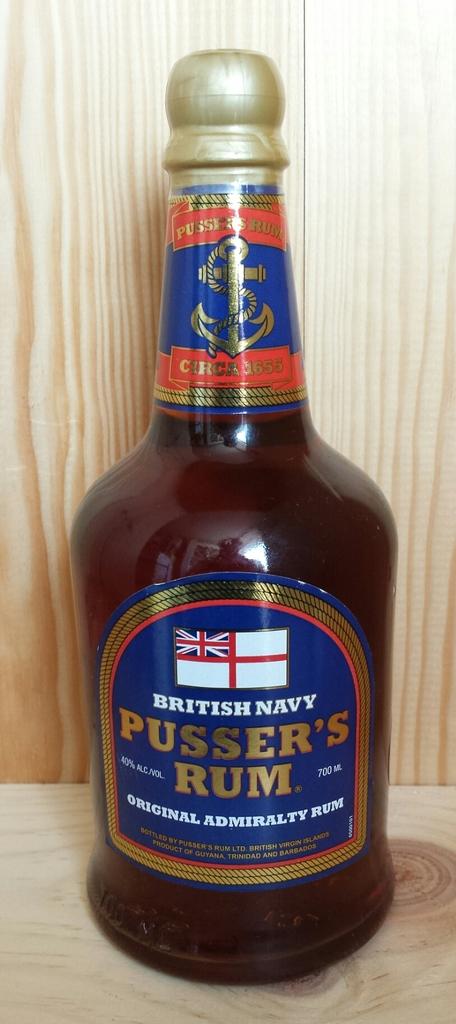What percentage of alcohol is in the rum?
Your answer should be compact. 40%. What is the brand?
Your answer should be very brief. Pusser's rum. 